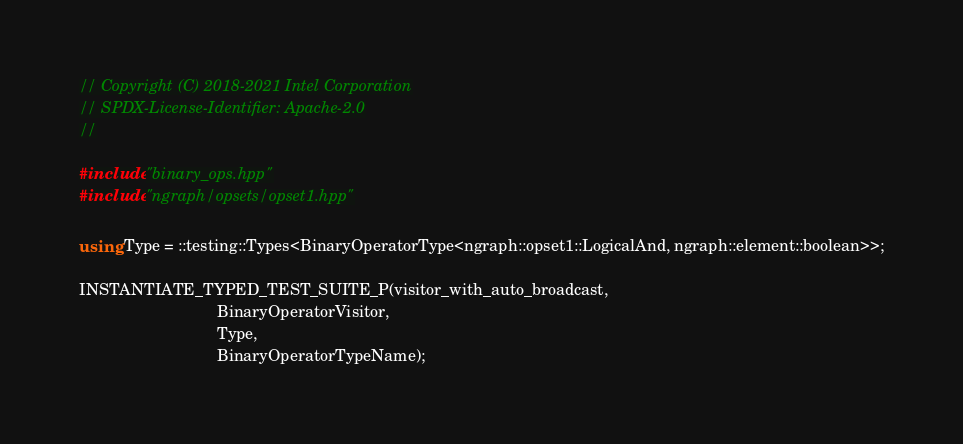Convert code to text. <code><loc_0><loc_0><loc_500><loc_500><_C++_>// Copyright (C) 2018-2021 Intel Corporation
// SPDX-License-Identifier: Apache-2.0
//

#include "binary_ops.hpp"
#include "ngraph/opsets/opset1.hpp"

using Type = ::testing::Types<BinaryOperatorType<ngraph::opset1::LogicalAnd, ngraph::element::boolean>>;

INSTANTIATE_TYPED_TEST_SUITE_P(visitor_with_auto_broadcast,
                               BinaryOperatorVisitor,
                               Type,
                               BinaryOperatorTypeName);
</code> 